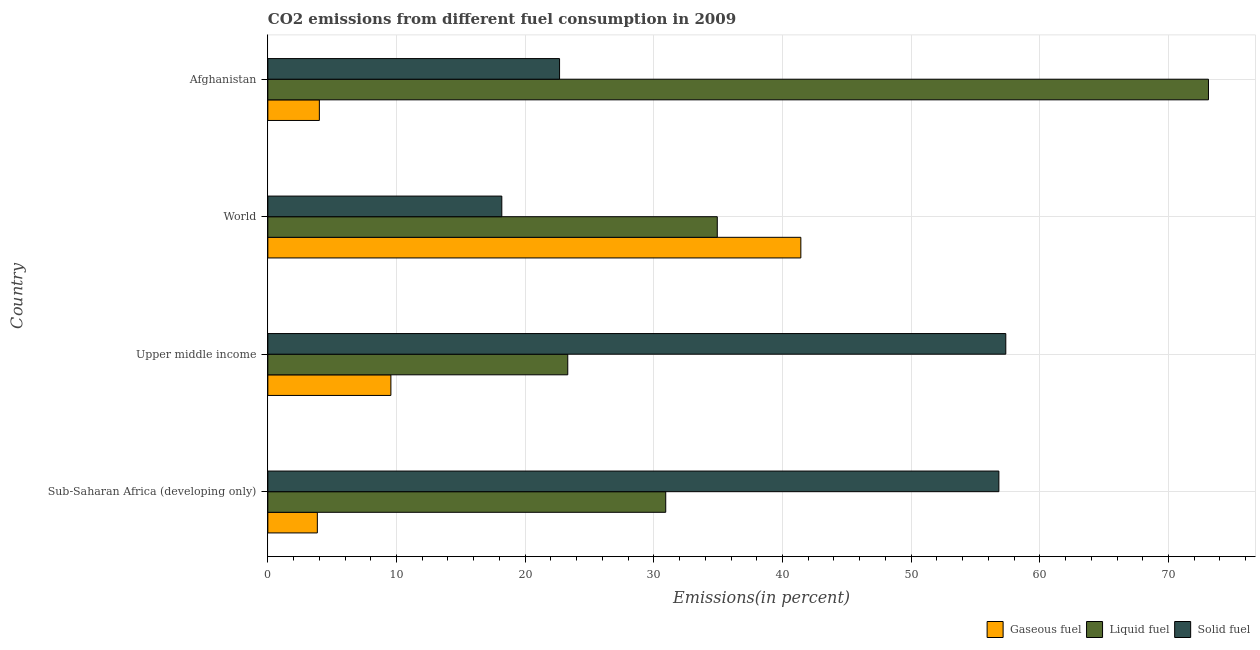Are the number of bars per tick equal to the number of legend labels?
Provide a short and direct response. Yes. What is the label of the 3rd group of bars from the top?
Your answer should be very brief. Upper middle income. In how many cases, is the number of bars for a given country not equal to the number of legend labels?
Ensure brevity in your answer.  0. What is the percentage of solid fuel emission in Afghanistan?
Provide a short and direct response. 22.67. Across all countries, what is the maximum percentage of gaseous fuel emission?
Your answer should be compact. 41.43. Across all countries, what is the minimum percentage of gaseous fuel emission?
Make the answer very short. 3.85. In which country was the percentage of solid fuel emission maximum?
Ensure brevity in your answer.  Upper middle income. In which country was the percentage of gaseous fuel emission minimum?
Offer a terse response. Sub-Saharan Africa (developing only). What is the total percentage of solid fuel emission in the graph?
Provide a succinct answer. 155.03. What is the difference between the percentage of gaseous fuel emission in Sub-Saharan Africa (developing only) and that in World?
Offer a very short reply. -37.58. What is the difference between the percentage of gaseous fuel emission in World and the percentage of liquid fuel emission in Afghanistan?
Your answer should be compact. -31.68. What is the average percentage of solid fuel emission per country?
Your response must be concise. 38.76. What is the difference between the percentage of gaseous fuel emission and percentage of solid fuel emission in Afghanistan?
Make the answer very short. -18.67. In how many countries, is the percentage of gaseous fuel emission greater than 72 %?
Ensure brevity in your answer.  0. What is the ratio of the percentage of gaseous fuel emission in Upper middle income to that in World?
Provide a short and direct response. 0.23. What is the difference between the highest and the second highest percentage of solid fuel emission?
Keep it short and to the point. 0.54. What is the difference between the highest and the lowest percentage of liquid fuel emission?
Ensure brevity in your answer.  49.8. In how many countries, is the percentage of solid fuel emission greater than the average percentage of solid fuel emission taken over all countries?
Ensure brevity in your answer.  2. Is the sum of the percentage of liquid fuel emission in Upper middle income and World greater than the maximum percentage of solid fuel emission across all countries?
Provide a short and direct response. Yes. What does the 1st bar from the top in World represents?
Offer a terse response. Solid fuel. What does the 3rd bar from the bottom in Sub-Saharan Africa (developing only) represents?
Your answer should be very brief. Solid fuel. How many bars are there?
Keep it short and to the point. 12. Are all the bars in the graph horizontal?
Provide a short and direct response. Yes. Are the values on the major ticks of X-axis written in scientific E-notation?
Provide a short and direct response. No. Does the graph contain any zero values?
Keep it short and to the point. No. How are the legend labels stacked?
Ensure brevity in your answer.  Horizontal. What is the title of the graph?
Provide a short and direct response. CO2 emissions from different fuel consumption in 2009. Does "Infant(male)" appear as one of the legend labels in the graph?
Keep it short and to the point. No. What is the label or title of the X-axis?
Make the answer very short. Emissions(in percent). What is the label or title of the Y-axis?
Offer a very short reply. Country. What is the Emissions(in percent) in Gaseous fuel in Sub-Saharan Africa (developing only)?
Your response must be concise. 3.85. What is the Emissions(in percent) of Liquid fuel in Sub-Saharan Africa (developing only)?
Provide a succinct answer. 30.93. What is the Emissions(in percent) in Solid fuel in Sub-Saharan Africa (developing only)?
Provide a short and direct response. 56.82. What is the Emissions(in percent) of Gaseous fuel in Upper middle income?
Offer a terse response. 9.56. What is the Emissions(in percent) in Liquid fuel in Upper middle income?
Offer a very short reply. 23.31. What is the Emissions(in percent) in Solid fuel in Upper middle income?
Keep it short and to the point. 57.35. What is the Emissions(in percent) in Gaseous fuel in World?
Offer a terse response. 41.43. What is the Emissions(in percent) in Liquid fuel in World?
Your response must be concise. 34.93. What is the Emissions(in percent) in Solid fuel in World?
Make the answer very short. 18.18. What is the Emissions(in percent) of Gaseous fuel in Afghanistan?
Your answer should be compact. 4. What is the Emissions(in percent) in Liquid fuel in Afghanistan?
Ensure brevity in your answer.  73.11. What is the Emissions(in percent) in Solid fuel in Afghanistan?
Offer a very short reply. 22.67. Across all countries, what is the maximum Emissions(in percent) in Gaseous fuel?
Provide a succinct answer. 41.43. Across all countries, what is the maximum Emissions(in percent) in Liquid fuel?
Provide a succinct answer. 73.11. Across all countries, what is the maximum Emissions(in percent) of Solid fuel?
Your answer should be compact. 57.35. Across all countries, what is the minimum Emissions(in percent) in Gaseous fuel?
Your response must be concise. 3.85. Across all countries, what is the minimum Emissions(in percent) in Liquid fuel?
Provide a succinct answer. 23.31. Across all countries, what is the minimum Emissions(in percent) in Solid fuel?
Your answer should be very brief. 18.18. What is the total Emissions(in percent) of Gaseous fuel in the graph?
Make the answer very short. 58.84. What is the total Emissions(in percent) of Liquid fuel in the graph?
Your response must be concise. 162.27. What is the total Emissions(in percent) of Solid fuel in the graph?
Your answer should be very brief. 155.03. What is the difference between the Emissions(in percent) in Gaseous fuel in Sub-Saharan Africa (developing only) and that in Upper middle income?
Keep it short and to the point. -5.72. What is the difference between the Emissions(in percent) in Liquid fuel in Sub-Saharan Africa (developing only) and that in Upper middle income?
Offer a terse response. 7.61. What is the difference between the Emissions(in percent) of Solid fuel in Sub-Saharan Africa (developing only) and that in Upper middle income?
Your answer should be compact. -0.54. What is the difference between the Emissions(in percent) of Gaseous fuel in Sub-Saharan Africa (developing only) and that in World?
Keep it short and to the point. -37.58. What is the difference between the Emissions(in percent) of Liquid fuel in Sub-Saharan Africa (developing only) and that in World?
Keep it short and to the point. -4.01. What is the difference between the Emissions(in percent) in Solid fuel in Sub-Saharan Africa (developing only) and that in World?
Provide a short and direct response. 38.63. What is the difference between the Emissions(in percent) of Gaseous fuel in Sub-Saharan Africa (developing only) and that in Afghanistan?
Your answer should be compact. -0.16. What is the difference between the Emissions(in percent) of Liquid fuel in Sub-Saharan Africa (developing only) and that in Afghanistan?
Give a very brief answer. -42.18. What is the difference between the Emissions(in percent) of Solid fuel in Sub-Saharan Africa (developing only) and that in Afghanistan?
Ensure brevity in your answer.  34.14. What is the difference between the Emissions(in percent) of Gaseous fuel in Upper middle income and that in World?
Make the answer very short. -31.86. What is the difference between the Emissions(in percent) in Liquid fuel in Upper middle income and that in World?
Your response must be concise. -11.62. What is the difference between the Emissions(in percent) in Solid fuel in Upper middle income and that in World?
Provide a short and direct response. 39.17. What is the difference between the Emissions(in percent) of Gaseous fuel in Upper middle income and that in Afghanistan?
Your answer should be very brief. 5.56. What is the difference between the Emissions(in percent) of Liquid fuel in Upper middle income and that in Afghanistan?
Offer a terse response. -49.8. What is the difference between the Emissions(in percent) in Solid fuel in Upper middle income and that in Afghanistan?
Provide a succinct answer. 34.68. What is the difference between the Emissions(in percent) of Gaseous fuel in World and that in Afghanistan?
Provide a short and direct response. 37.42. What is the difference between the Emissions(in percent) of Liquid fuel in World and that in Afghanistan?
Make the answer very short. -38.17. What is the difference between the Emissions(in percent) of Solid fuel in World and that in Afghanistan?
Offer a terse response. -4.49. What is the difference between the Emissions(in percent) in Gaseous fuel in Sub-Saharan Africa (developing only) and the Emissions(in percent) in Liquid fuel in Upper middle income?
Give a very brief answer. -19.46. What is the difference between the Emissions(in percent) in Gaseous fuel in Sub-Saharan Africa (developing only) and the Emissions(in percent) in Solid fuel in Upper middle income?
Offer a very short reply. -53.51. What is the difference between the Emissions(in percent) in Liquid fuel in Sub-Saharan Africa (developing only) and the Emissions(in percent) in Solid fuel in Upper middle income?
Provide a succinct answer. -26.43. What is the difference between the Emissions(in percent) of Gaseous fuel in Sub-Saharan Africa (developing only) and the Emissions(in percent) of Liquid fuel in World?
Provide a succinct answer. -31.08. What is the difference between the Emissions(in percent) in Gaseous fuel in Sub-Saharan Africa (developing only) and the Emissions(in percent) in Solid fuel in World?
Give a very brief answer. -14.34. What is the difference between the Emissions(in percent) in Liquid fuel in Sub-Saharan Africa (developing only) and the Emissions(in percent) in Solid fuel in World?
Give a very brief answer. 12.74. What is the difference between the Emissions(in percent) of Gaseous fuel in Sub-Saharan Africa (developing only) and the Emissions(in percent) of Liquid fuel in Afghanistan?
Your answer should be very brief. -69.26. What is the difference between the Emissions(in percent) in Gaseous fuel in Sub-Saharan Africa (developing only) and the Emissions(in percent) in Solid fuel in Afghanistan?
Provide a succinct answer. -18.83. What is the difference between the Emissions(in percent) in Liquid fuel in Sub-Saharan Africa (developing only) and the Emissions(in percent) in Solid fuel in Afghanistan?
Keep it short and to the point. 8.25. What is the difference between the Emissions(in percent) of Gaseous fuel in Upper middle income and the Emissions(in percent) of Liquid fuel in World?
Give a very brief answer. -25.37. What is the difference between the Emissions(in percent) of Gaseous fuel in Upper middle income and the Emissions(in percent) of Solid fuel in World?
Provide a succinct answer. -8.62. What is the difference between the Emissions(in percent) in Liquid fuel in Upper middle income and the Emissions(in percent) in Solid fuel in World?
Ensure brevity in your answer.  5.13. What is the difference between the Emissions(in percent) of Gaseous fuel in Upper middle income and the Emissions(in percent) of Liquid fuel in Afghanistan?
Provide a succinct answer. -63.54. What is the difference between the Emissions(in percent) of Gaseous fuel in Upper middle income and the Emissions(in percent) of Solid fuel in Afghanistan?
Ensure brevity in your answer.  -13.11. What is the difference between the Emissions(in percent) in Liquid fuel in Upper middle income and the Emissions(in percent) in Solid fuel in Afghanistan?
Offer a terse response. 0.64. What is the difference between the Emissions(in percent) of Gaseous fuel in World and the Emissions(in percent) of Liquid fuel in Afghanistan?
Keep it short and to the point. -31.68. What is the difference between the Emissions(in percent) in Gaseous fuel in World and the Emissions(in percent) in Solid fuel in Afghanistan?
Keep it short and to the point. 18.75. What is the difference between the Emissions(in percent) of Liquid fuel in World and the Emissions(in percent) of Solid fuel in Afghanistan?
Offer a terse response. 12.26. What is the average Emissions(in percent) in Gaseous fuel per country?
Your response must be concise. 14.71. What is the average Emissions(in percent) in Liquid fuel per country?
Make the answer very short. 40.57. What is the average Emissions(in percent) of Solid fuel per country?
Offer a terse response. 38.76. What is the difference between the Emissions(in percent) of Gaseous fuel and Emissions(in percent) of Liquid fuel in Sub-Saharan Africa (developing only)?
Give a very brief answer. -27.08. What is the difference between the Emissions(in percent) of Gaseous fuel and Emissions(in percent) of Solid fuel in Sub-Saharan Africa (developing only)?
Ensure brevity in your answer.  -52.97. What is the difference between the Emissions(in percent) of Liquid fuel and Emissions(in percent) of Solid fuel in Sub-Saharan Africa (developing only)?
Your response must be concise. -25.89. What is the difference between the Emissions(in percent) of Gaseous fuel and Emissions(in percent) of Liquid fuel in Upper middle income?
Provide a succinct answer. -13.75. What is the difference between the Emissions(in percent) of Gaseous fuel and Emissions(in percent) of Solid fuel in Upper middle income?
Your answer should be very brief. -47.79. What is the difference between the Emissions(in percent) of Liquid fuel and Emissions(in percent) of Solid fuel in Upper middle income?
Keep it short and to the point. -34.04. What is the difference between the Emissions(in percent) in Gaseous fuel and Emissions(in percent) in Liquid fuel in World?
Ensure brevity in your answer.  6.49. What is the difference between the Emissions(in percent) in Gaseous fuel and Emissions(in percent) in Solid fuel in World?
Offer a very short reply. 23.24. What is the difference between the Emissions(in percent) in Liquid fuel and Emissions(in percent) in Solid fuel in World?
Ensure brevity in your answer.  16.75. What is the difference between the Emissions(in percent) of Gaseous fuel and Emissions(in percent) of Liquid fuel in Afghanistan?
Keep it short and to the point. -69.1. What is the difference between the Emissions(in percent) in Gaseous fuel and Emissions(in percent) in Solid fuel in Afghanistan?
Give a very brief answer. -18.67. What is the difference between the Emissions(in percent) in Liquid fuel and Emissions(in percent) in Solid fuel in Afghanistan?
Your answer should be compact. 50.43. What is the ratio of the Emissions(in percent) of Gaseous fuel in Sub-Saharan Africa (developing only) to that in Upper middle income?
Offer a very short reply. 0.4. What is the ratio of the Emissions(in percent) in Liquid fuel in Sub-Saharan Africa (developing only) to that in Upper middle income?
Give a very brief answer. 1.33. What is the ratio of the Emissions(in percent) in Solid fuel in Sub-Saharan Africa (developing only) to that in Upper middle income?
Your answer should be very brief. 0.99. What is the ratio of the Emissions(in percent) of Gaseous fuel in Sub-Saharan Africa (developing only) to that in World?
Offer a very short reply. 0.09. What is the ratio of the Emissions(in percent) in Liquid fuel in Sub-Saharan Africa (developing only) to that in World?
Provide a succinct answer. 0.89. What is the ratio of the Emissions(in percent) in Solid fuel in Sub-Saharan Africa (developing only) to that in World?
Provide a short and direct response. 3.12. What is the ratio of the Emissions(in percent) in Gaseous fuel in Sub-Saharan Africa (developing only) to that in Afghanistan?
Your response must be concise. 0.96. What is the ratio of the Emissions(in percent) in Liquid fuel in Sub-Saharan Africa (developing only) to that in Afghanistan?
Make the answer very short. 0.42. What is the ratio of the Emissions(in percent) in Solid fuel in Sub-Saharan Africa (developing only) to that in Afghanistan?
Keep it short and to the point. 2.51. What is the ratio of the Emissions(in percent) of Gaseous fuel in Upper middle income to that in World?
Offer a very short reply. 0.23. What is the ratio of the Emissions(in percent) of Liquid fuel in Upper middle income to that in World?
Your response must be concise. 0.67. What is the ratio of the Emissions(in percent) in Solid fuel in Upper middle income to that in World?
Provide a succinct answer. 3.15. What is the ratio of the Emissions(in percent) of Gaseous fuel in Upper middle income to that in Afghanistan?
Your answer should be very brief. 2.39. What is the ratio of the Emissions(in percent) in Liquid fuel in Upper middle income to that in Afghanistan?
Offer a terse response. 0.32. What is the ratio of the Emissions(in percent) in Solid fuel in Upper middle income to that in Afghanistan?
Offer a terse response. 2.53. What is the ratio of the Emissions(in percent) of Gaseous fuel in World to that in Afghanistan?
Make the answer very short. 10.35. What is the ratio of the Emissions(in percent) in Liquid fuel in World to that in Afghanistan?
Your answer should be compact. 0.48. What is the ratio of the Emissions(in percent) of Solid fuel in World to that in Afghanistan?
Keep it short and to the point. 0.8. What is the difference between the highest and the second highest Emissions(in percent) of Gaseous fuel?
Your answer should be very brief. 31.86. What is the difference between the highest and the second highest Emissions(in percent) in Liquid fuel?
Give a very brief answer. 38.17. What is the difference between the highest and the second highest Emissions(in percent) in Solid fuel?
Provide a succinct answer. 0.54. What is the difference between the highest and the lowest Emissions(in percent) of Gaseous fuel?
Give a very brief answer. 37.58. What is the difference between the highest and the lowest Emissions(in percent) of Liquid fuel?
Offer a very short reply. 49.8. What is the difference between the highest and the lowest Emissions(in percent) in Solid fuel?
Make the answer very short. 39.17. 